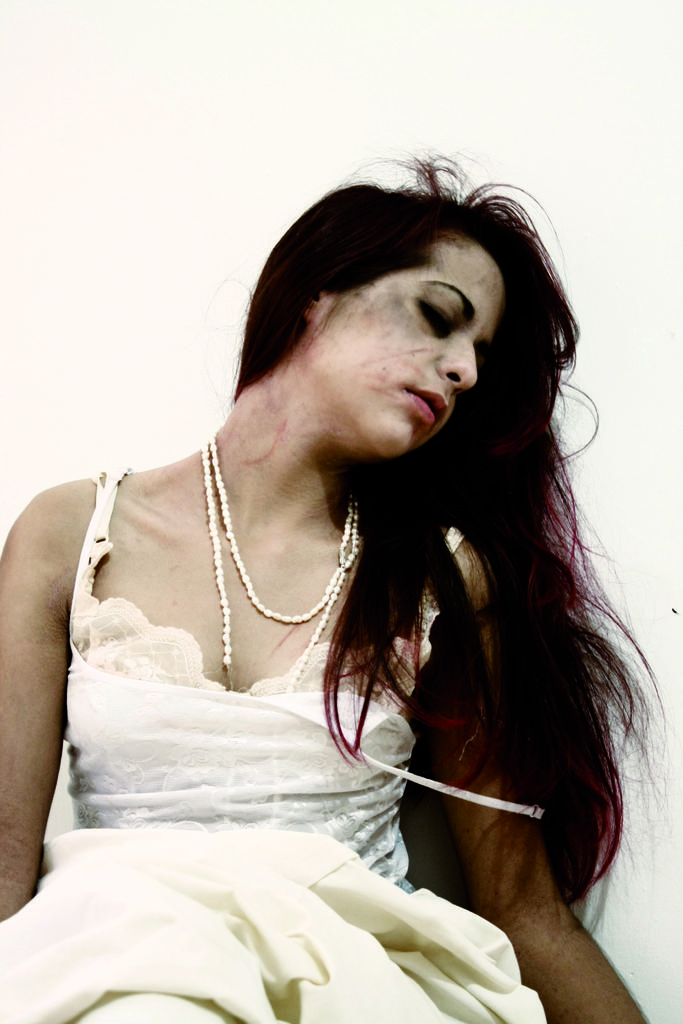Who is the main subject in the image? There is a woman in the image. What is the woman wearing? The woman is wearing white clothes. What is the color of the background in the image? The background of the image is white in color. What type of scene is being exchanged between the woman and the man in the image? There is no man present in the image, and no scene is being exchanged between the woman and anyone else. 